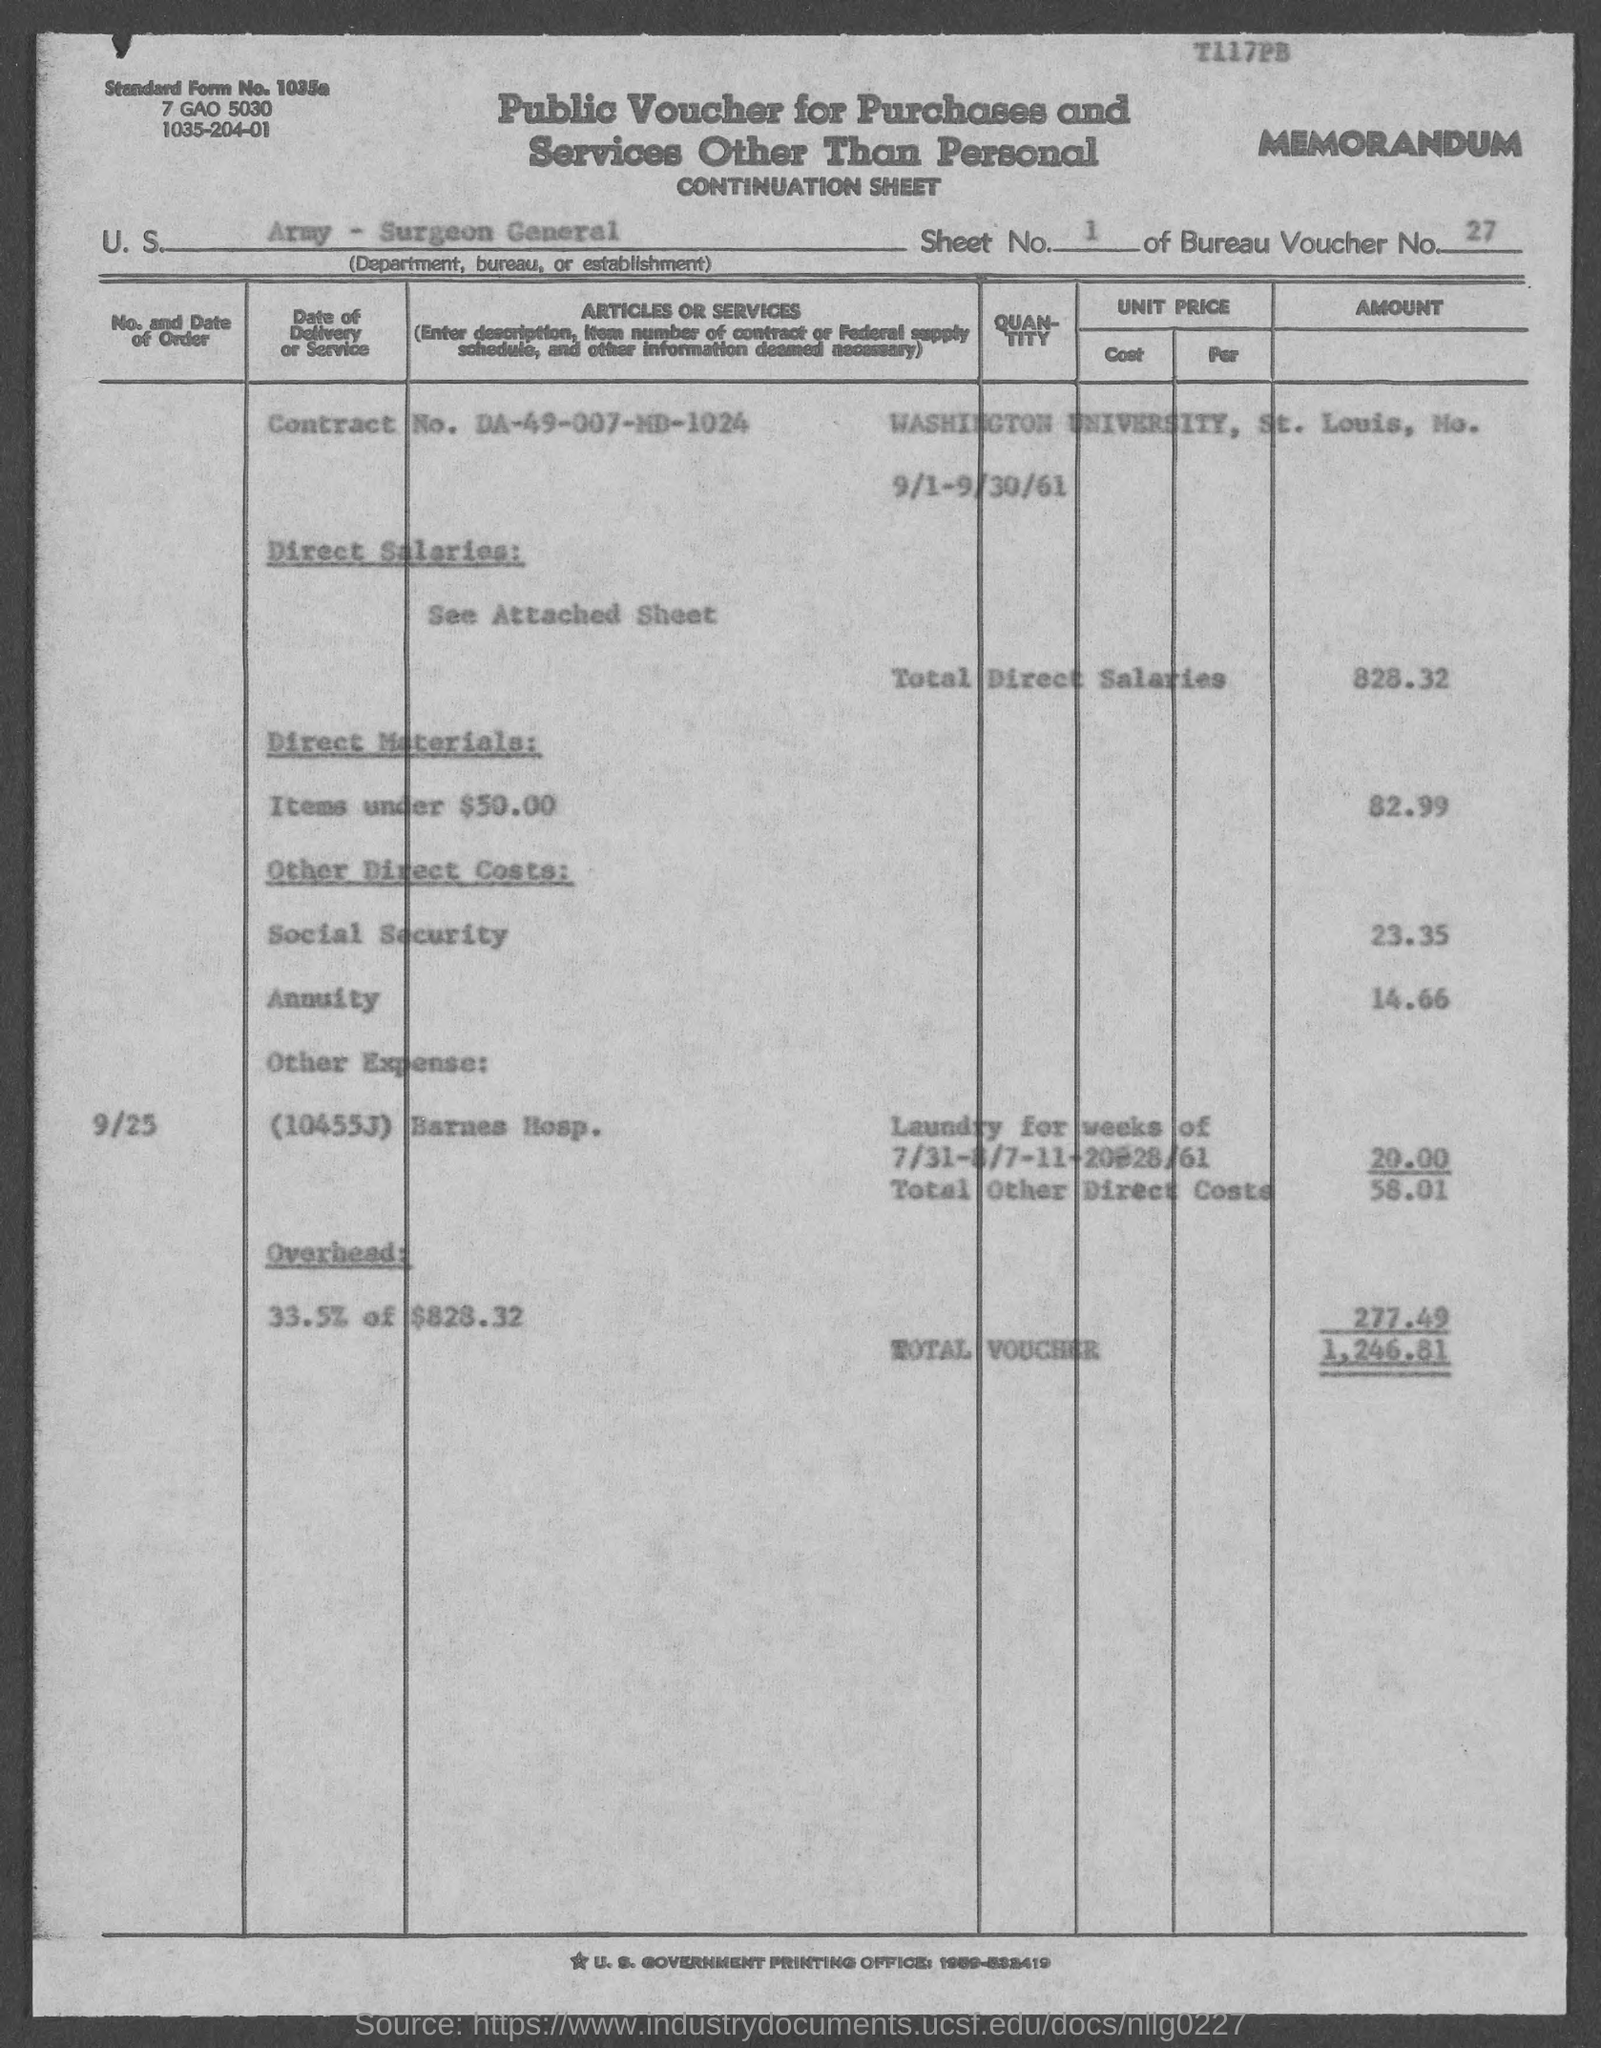Specify some key components in this picture. What is the standard form number? Washington University is located in St. Louis, a city in the United States. The total direct salaries is 828.32. The voucher number is 27. Other direct costs, including totals of $58.01, are [description of other direct costs and their purpose or significance]. 